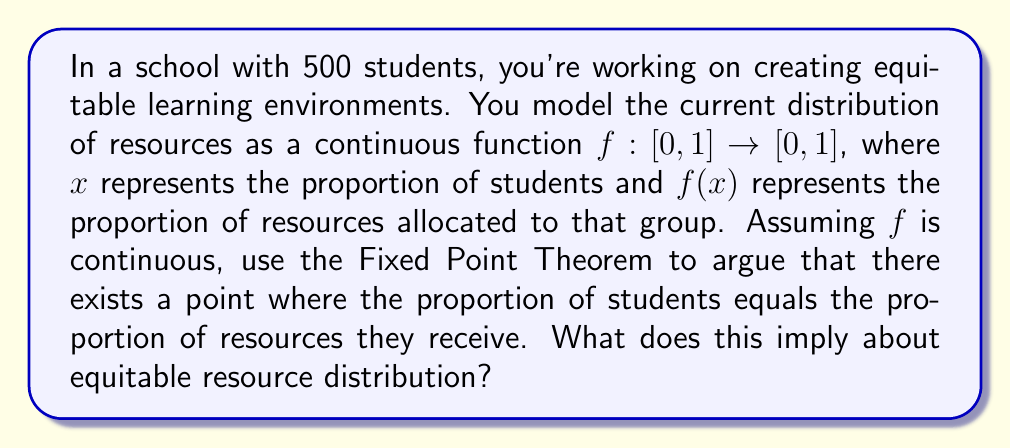Can you solve this math problem? To solve this problem, we'll use Brouwer's Fixed Point Theorem and interpret its meaning in the context of equitable learning environments.

1. Brouwer's Fixed Point Theorem states that for any continuous function $f: [0,1] \rightarrow [0,1]$, there exists at least one point $x_0 \in [0,1]$ such that $f(x_0) = x_0$.

2. In our case:
   - $x$ represents the proportion of students (from 0 to 1)
   - $f(x)$ represents the proportion of resources allocated to that group of students
   - The domain and codomain are both $[0,1]$, satisfying the conditions of the theorem

3. Applying the Fixed Point Theorem:
   There exists a point $x_0$ where $f(x_0) = x_0$

4. Interpretation:
   At this fixed point, the proportion of students $(x_0)$ equals the proportion of resources they receive $(f(x_0))$

5. Implications for equitable resource distribution:
   - This fixed point represents a "fair" distribution for at least one group of students
   - However, it doesn't guarantee fairness for all groups
   - It provides a starting point for identifying and addressing inequities
   - Deviations from this fixed point in either direction indicate potential inequities:
     - If $f(x) > x$ for some $x$, that group receives more resources proportionally
     - If $f(x) < x$ for some $x$, that group receives fewer resources proportionally

6. Limitations and considerations:
   - The model assumes a continuous distribution, which may not always be realistic
   - It doesn't account for varying needs among different student groups
   - Multiple fixed points may exist, requiring careful analysis of the entire function

By using this mathematical model, you can argue for the existence of at least one point of equity and use it as a benchmark to identify and address inequities in resource distribution across the student population.
Answer: The Fixed Point Theorem implies that there exists at least one point where the proportion of students equals the proportion of resources they receive, providing a baseline for equitable distribution. However, this doesn't guarantee overall fairness, as inequities may still exist for other groups. This model serves as a starting point for identifying and addressing resource allocation disparities across the student population. 